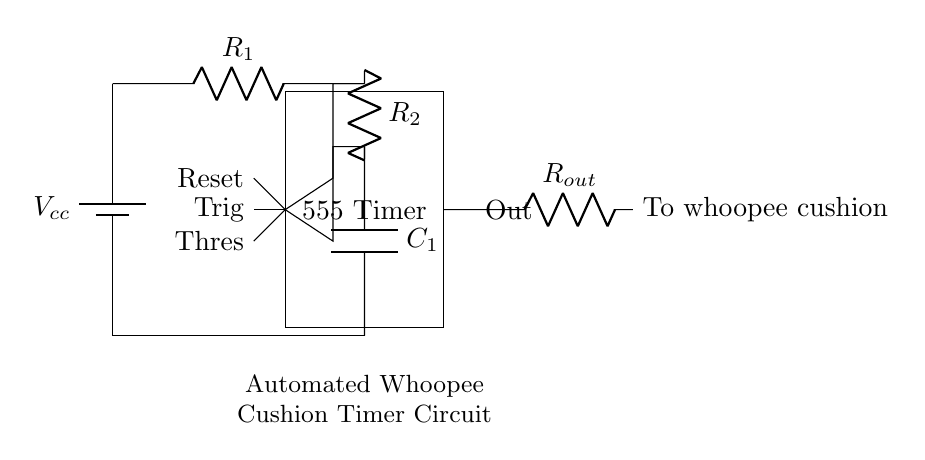What kind of timer is used in this circuit? The circuit uses a 555 Timer, which is a popular integrated circuit for timing applications. It is clearly labeled in the circuit diagram as "555 Timer".
Answer: 555 Timer How many resistors are present in the circuit? There are two resistors labeled R1 and R2 in the circuit diagram, which can be identified from the labels next to the resistor symbols.
Answer: 2 What is the purpose of the capacitor in this circuit? The capacitor, labeled C1, is used for timing purposes in the 555 Timer circuit. It stores and releases electrical energy to create a timing interval, helping to control the duration of the whoopee cushion activation.
Answer: Timing What happens at the output of the timer? The output labeled "Out" provides a signal that is used to activate the whoopee cushion. From the diagram, it shows that the output signal is connected through a resistor Rout to the whoopee cushion.
Answer: Activates whoopee cushion What is the relationship between R1, R2, and C1? R1, R2, and C1 work together to define the timing cycle of the 555 Timer. The values of these components determine the charging and discharging time of the capacitor C1, affecting how long the output stays high or low for the whoopee cushion.
Answer: Timing cycle 